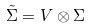<formula> <loc_0><loc_0><loc_500><loc_500>\tilde { \Sigma } = V \otimes \Sigma</formula> 